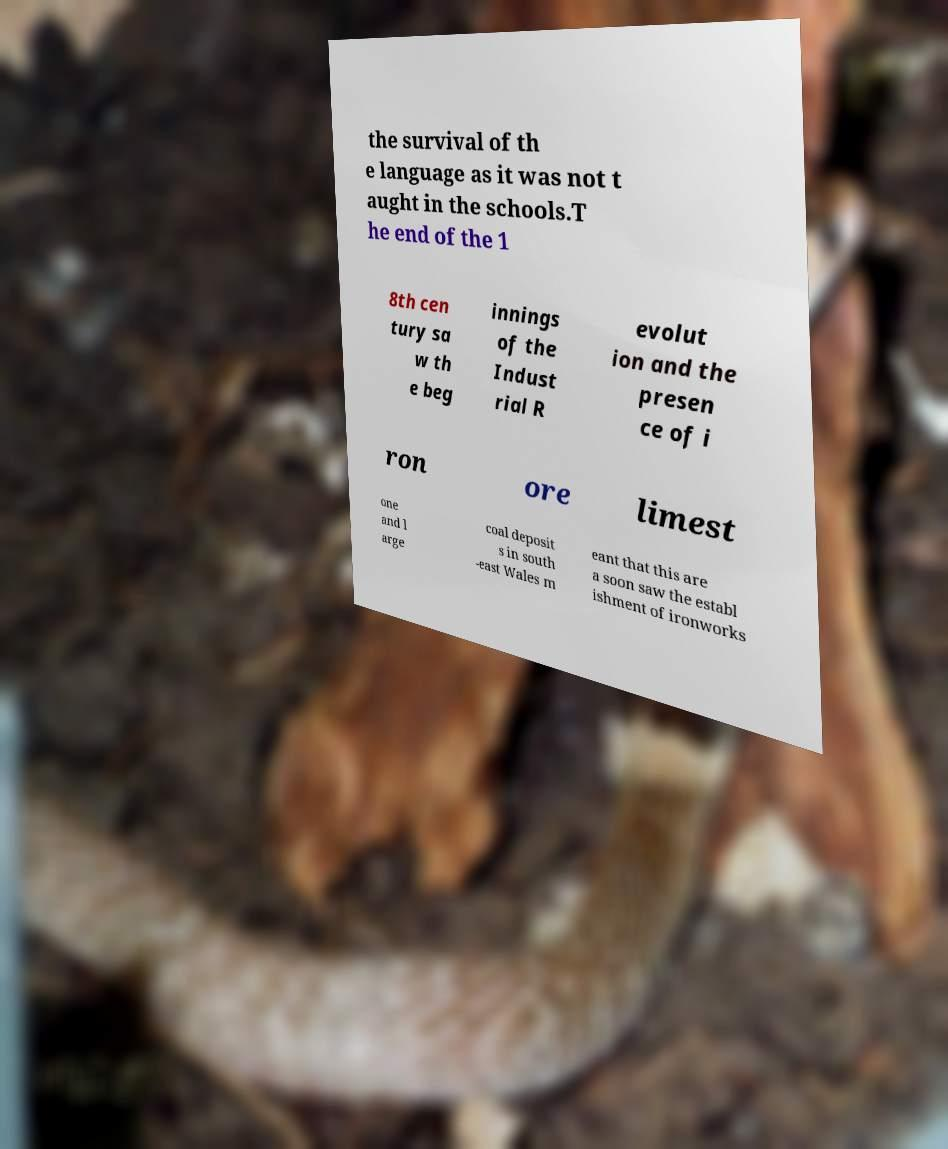Could you assist in decoding the text presented in this image and type it out clearly? the survival of th e language as it was not t aught in the schools.T he end of the 1 8th cen tury sa w th e beg innings of the Indust rial R evolut ion and the presen ce of i ron ore limest one and l arge coal deposit s in south -east Wales m eant that this are a soon saw the establ ishment of ironworks 